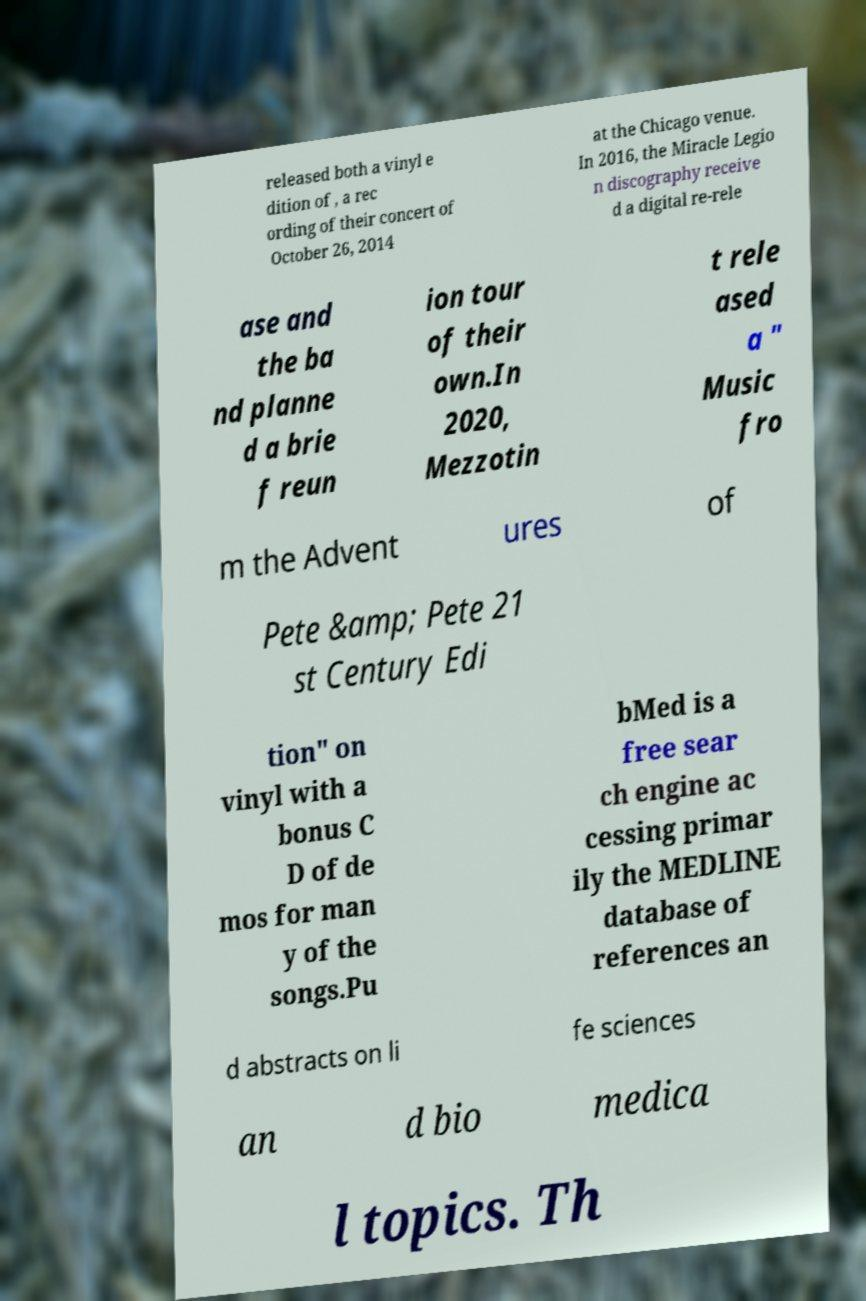For documentation purposes, I need the text within this image transcribed. Could you provide that? released both a vinyl e dition of , a rec ording of their concert of October 26, 2014 at the Chicago venue. In 2016, the Miracle Legio n discography receive d a digital re-rele ase and the ba nd planne d a brie f reun ion tour of their own.In 2020, Mezzotin t rele ased a " Music fro m the Advent ures of Pete &amp; Pete 21 st Century Edi tion" on vinyl with a bonus C D of de mos for man y of the songs.Pu bMed is a free sear ch engine ac cessing primar ily the MEDLINE database of references an d abstracts on li fe sciences an d bio medica l topics. Th 